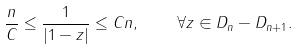<formula> <loc_0><loc_0><loc_500><loc_500>\frac { n } { C } \leq \frac { 1 } { | 1 - z | } \leq C n , \quad \forall z \in D _ { n } - D _ { n + 1 } .</formula> 